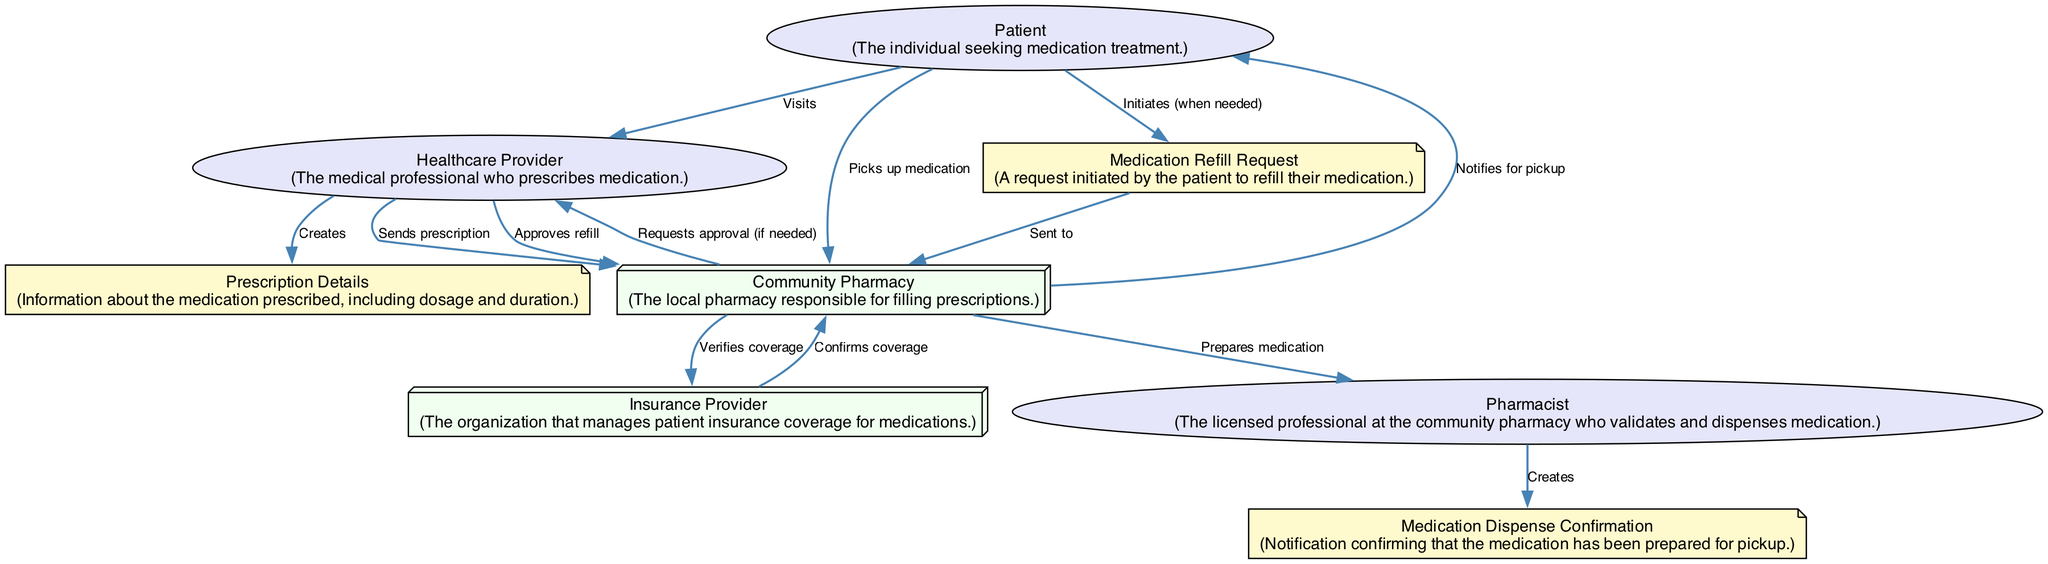What is the total number of actors in the diagram? The diagram features three actors: the Patient, the Healthcare Provider, and the Pharmacist. Counting these individual entities gives a total of three actors.
Answer: 3 Which system does the Community Pharmacy interact with to verify coverage? In the diagram, the Community Pharmacy interacts with the Insurance Provider to verify coverage for the medication. This interaction is depicted directly between the Community Pharmacy and the Insurance Provider.
Answer: Insurance Provider What type of request does the Patient initiate when they need more medication? The Patient initiates a Medication Refill Request when they need more medication, as shown in the interaction sequence where the Patient's action leads to this request.
Answer: Medication Refill Request How many edges are there in the diagram? The interactions between the elements create 13 edges in total, as each action or relationship between nodes is represented by an edge in the diagram. By counting each individual connection, we find there are 13 edges.
Answer: 13 Who is responsible for preparing the medication? The Pharmacist is responsible for preparing the medication in the pharmacy. This responsibility is illustrated in the interaction where the Community Pharmacy prepares the medication involving the Pharmacist.
Answer: Pharmacist What action occurs after the Healthcare Provider sends the prescription to the Community Pharmacy? After the Healthcare Provider sends the prescription to the Community Pharmacy, the Community Pharmacy interacts with the Insurance Provider to verify the coverage of the medication prescribed. This sequence follows logically after the sending action.
Answer: Verifies coverage Which actor gets notified for medication pickup? The Patient receives notification from the Community Pharmacy for medication pickup, indicating that the medication is ready for collection at the pharmacy. This relationship is clearly outlined in the interaction flow.
Answer: Patient What happens if a refill is needed after the initial prescription? If a refill is needed, the Patient initiates a Medication Refill Request, which begins a new sequence of interactions to request approval and process the refill from the Healthcare Provider and the Community Pharmacy. This flow reveals the necessary steps following the initial prescription.
Answer: Initiates request 